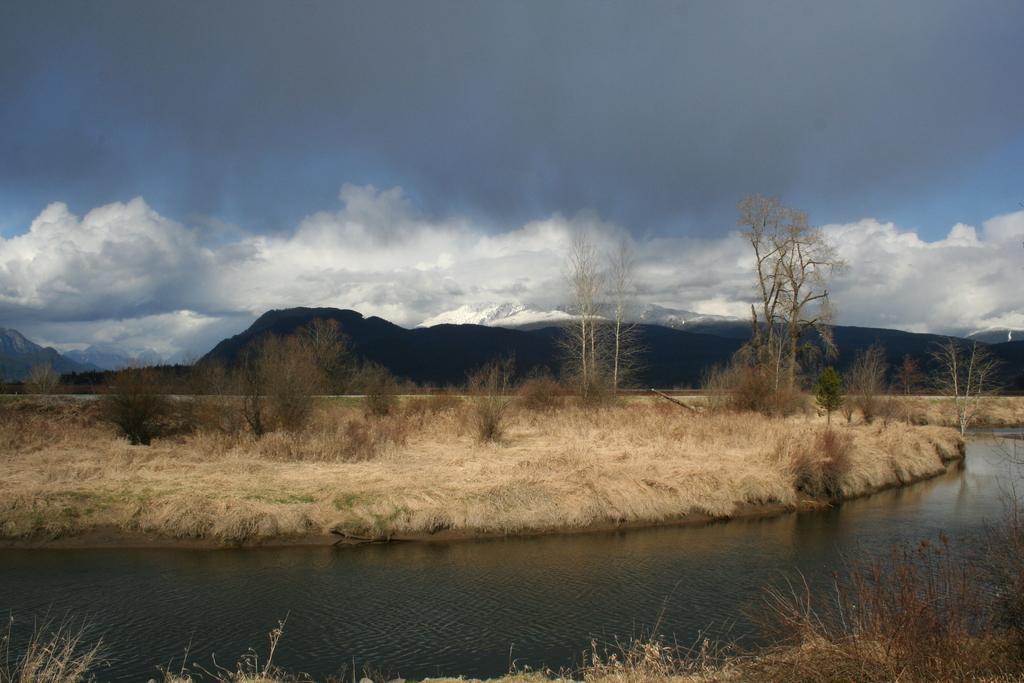In one or two sentences, can you explain what this image depicts? This image is taken outdoors. At the top of the image there is a sky with clouds. At the bottom of the image there is a ground with grass on it. In the middle of the image there is a lake with water and there is a ground with grass, a few plants and trees on it. In the background there are a few hills. 